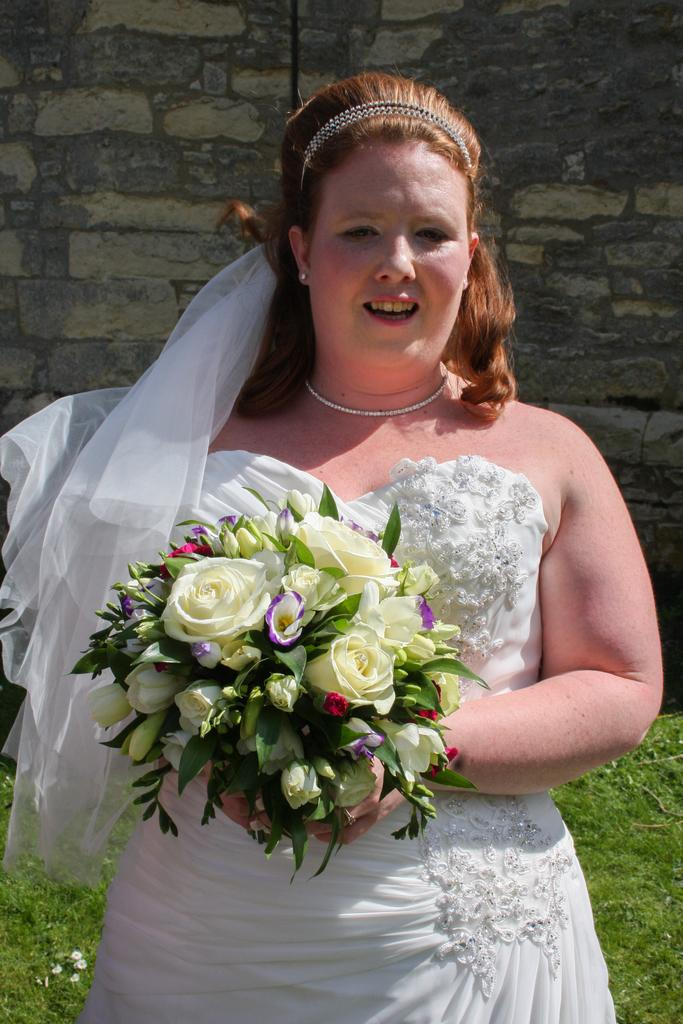Who is the main subject in the image? There is a lady in the image. What is the lady holding in the image? The lady is holding a flower bouquet. What type of natural environment can be seen in the image? There is grass visible in the image. What architectural feature is present in the image? There is a wall in the image. What is the lady's belief about the importance of education in the image? There is no information about the lady's beliefs or opinions in the image. 